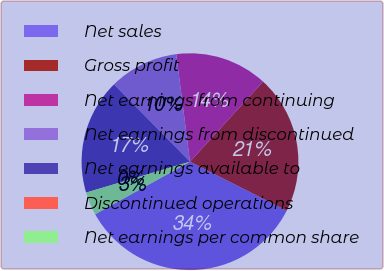Convert chart. <chart><loc_0><loc_0><loc_500><loc_500><pie_chart><fcel>Net sales<fcel>Gross profit<fcel>Net earnings from continuing<fcel>Net earnings from discontinued<fcel>Net earnings available to<fcel>Discontinued operations<fcel>Net earnings per common share<nl><fcel>34.48%<fcel>20.69%<fcel>13.79%<fcel>10.34%<fcel>17.24%<fcel>0.0%<fcel>3.45%<nl></chart> 